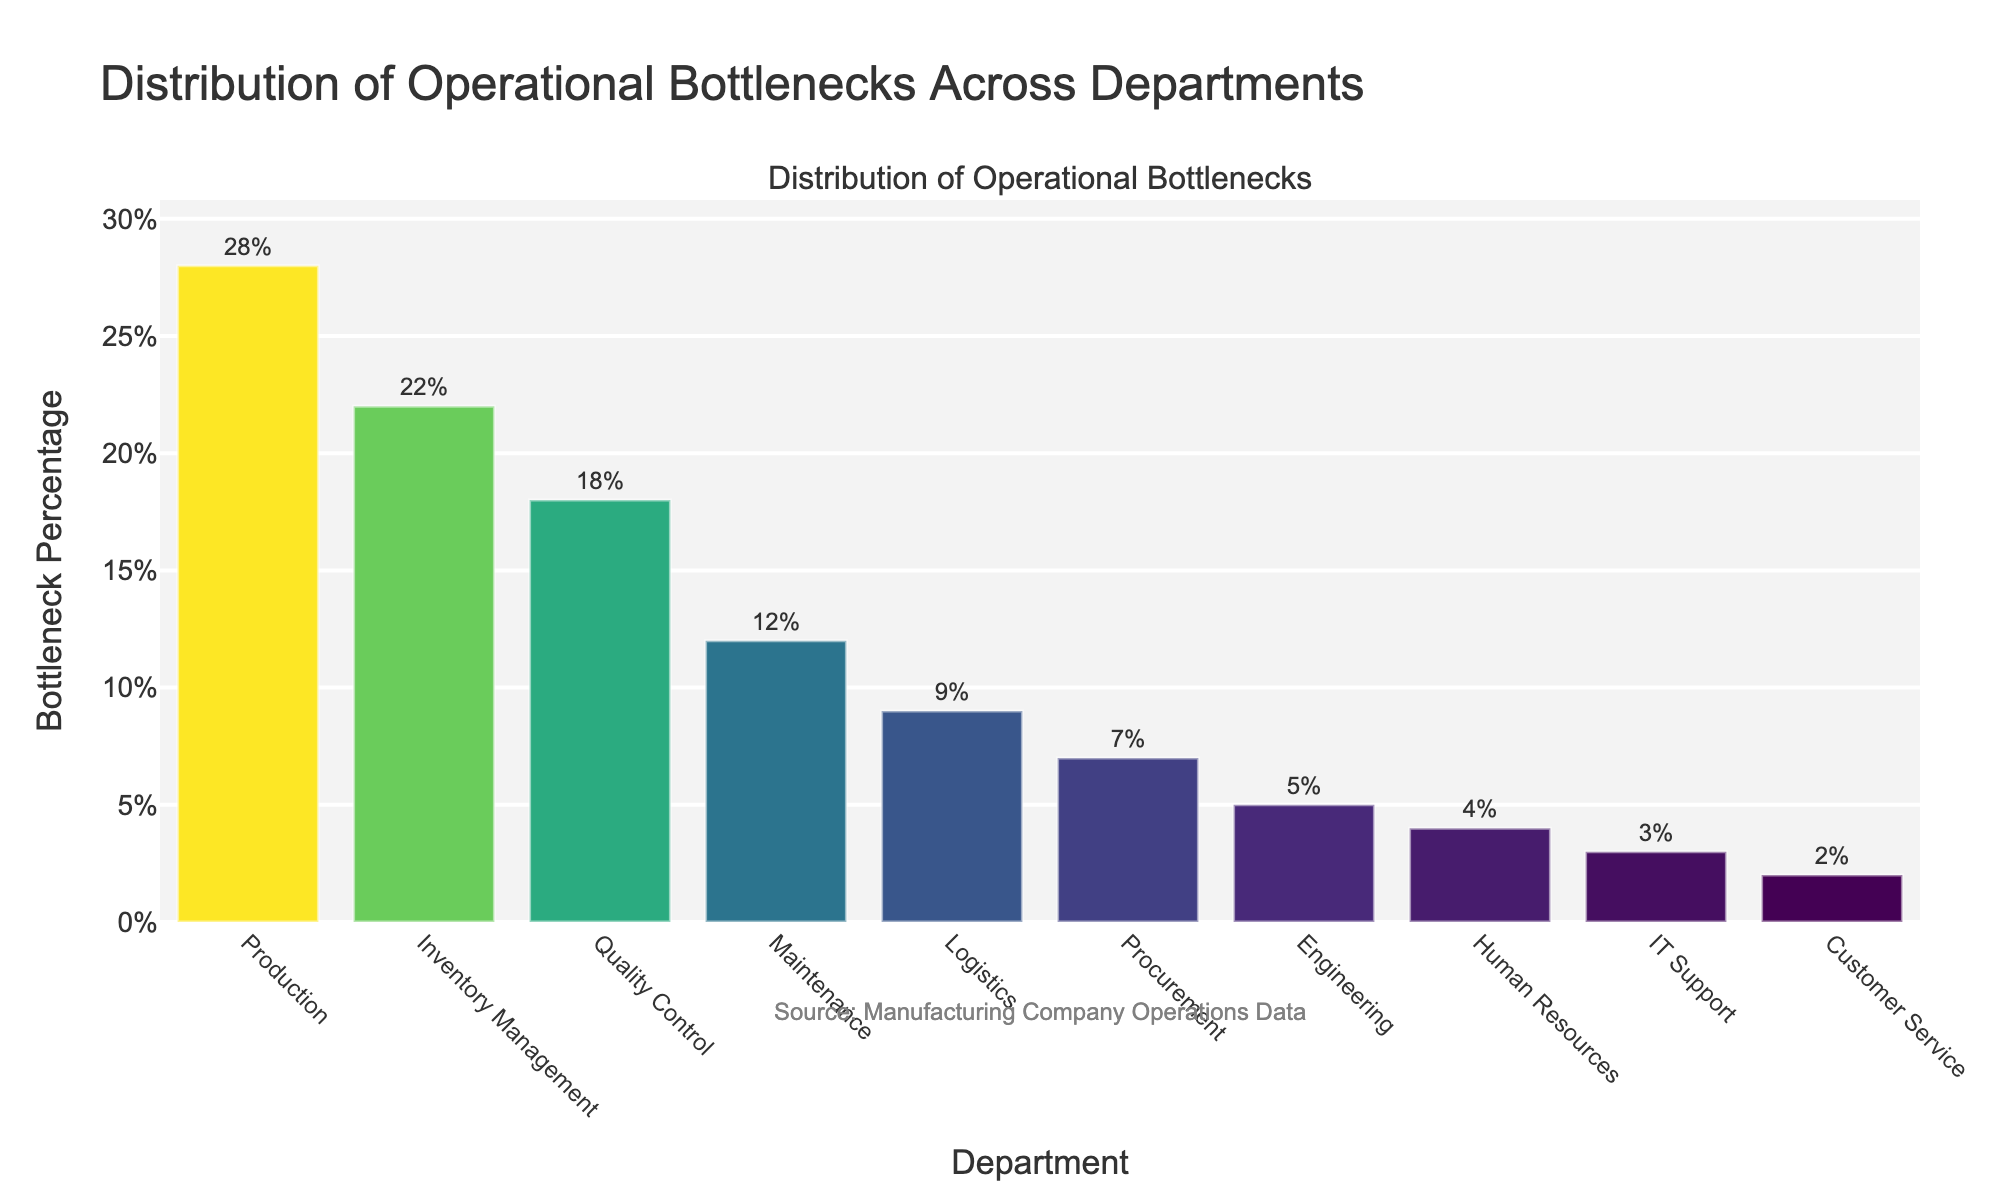Which department has the highest bottleneck percentage? The department with the highest bar in the chart represents the highest bottleneck percentage. This is the 'Production' department at 28%.
Answer: Production Which two departments have the lowest bottleneck percentages, and what are their values? The shortest bars in the chart indicate the departments with the lowest bottleneck percentages. These are 'Customer Service' and 'IT Support' with percentages of 2% and 3%, respectively.
Answer: Customer Service: 2%, IT Support: 3% By how much does the bottleneck percentage of Quality Control exceed that of Procurement? Compare the heights of the bars for 'Quality Control' and 'Procurement'. The bottleneck percentage for 'Quality Control' is 18%, and for 'Procurement', it is 7%. The difference is 18% - 7% = 11%.
Answer: 11% What is the average bottleneck percentage across all departments? Sum up all the bottleneck percentages and divide by the number of departments. (28+22+18+12+9+7+5+4+3+2)/10 = 110/10 = 11%.
Answer: 11% Which department's bottleneck percentage is just below Inventory Management? Look at the bar heights and find the one just below 'Inventory Management' at 22%, which is 'Quality Control' at 18%.
Answer: Quality Control Sum the bottleneck percentages of the three departments with the highest percentages. Identify the three departments with the highest bars: 'Production', 'Inventory Management', and 'Quality Control'. Their percentages are 28%, 22%, and 18%. Sum these values: 28 + 22 + 18 = 68%.
Answer: 68% What is the range of bottleneck percentages across departments? Find the difference between the highest and the lowest bottleneck percentages. The highest is 'Production' at 28%, and the lowest is 'Customer Service' at 2%. The range is 28% - 2% = 26%.
Answer: 26% Which departments have a bottleneck percentage greater than 15%? Look for departments where the bars are higher than the 15% mark. These departments are 'Production', 'Inventory Management', and 'Quality Control'.
Answer: Production, Inventory Management, Quality Control How does the bottleneck percentage of Engineering compare to that of Maintenance? Compare the bars for 'Engineering' and 'Maintenance'. 'Engineering' is at 5%, and 'Maintenance' is at 12%. The 'Maintenance' department has a higher bottleneck percentage by 12% - 5% = 7%.
Answer: Maintenance: 7% higher 